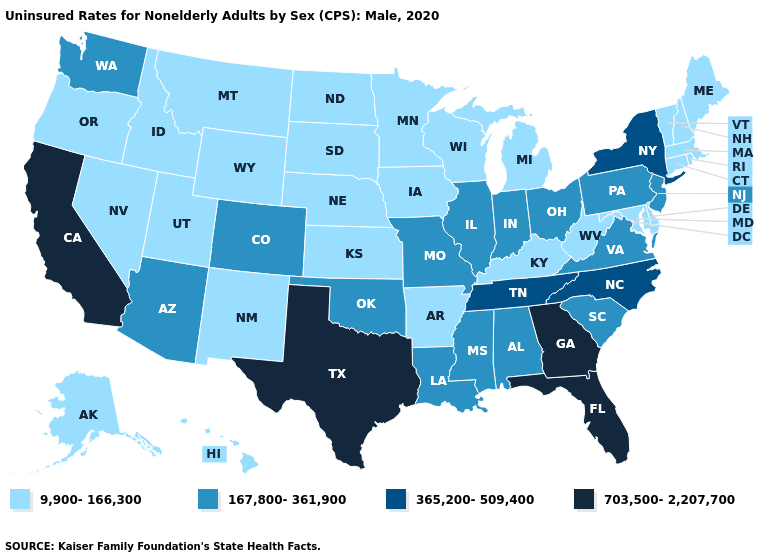Does the first symbol in the legend represent the smallest category?
Quick response, please. Yes. What is the highest value in the South ?
Quick response, please. 703,500-2,207,700. Which states have the lowest value in the USA?
Short answer required. Alaska, Arkansas, Connecticut, Delaware, Hawaii, Idaho, Iowa, Kansas, Kentucky, Maine, Maryland, Massachusetts, Michigan, Minnesota, Montana, Nebraska, Nevada, New Hampshire, New Mexico, North Dakota, Oregon, Rhode Island, South Dakota, Utah, Vermont, West Virginia, Wisconsin, Wyoming. Does Idaho have the same value as Kentucky?
Concise answer only. Yes. Does Washington have the lowest value in the West?
Write a very short answer. No. What is the value of New York?
Write a very short answer. 365,200-509,400. Among the states that border Pennsylvania , does Delaware have the lowest value?
Give a very brief answer. Yes. What is the value of North Dakota?
Concise answer only. 9,900-166,300. What is the value of South Carolina?
Quick response, please. 167,800-361,900. What is the highest value in the USA?
Answer briefly. 703,500-2,207,700. What is the value of Arkansas?
Concise answer only. 9,900-166,300. Which states hav the highest value in the MidWest?
Quick response, please. Illinois, Indiana, Missouri, Ohio. Does the map have missing data?
Short answer required. No. Name the states that have a value in the range 167,800-361,900?
Concise answer only. Alabama, Arizona, Colorado, Illinois, Indiana, Louisiana, Mississippi, Missouri, New Jersey, Ohio, Oklahoma, Pennsylvania, South Carolina, Virginia, Washington. 